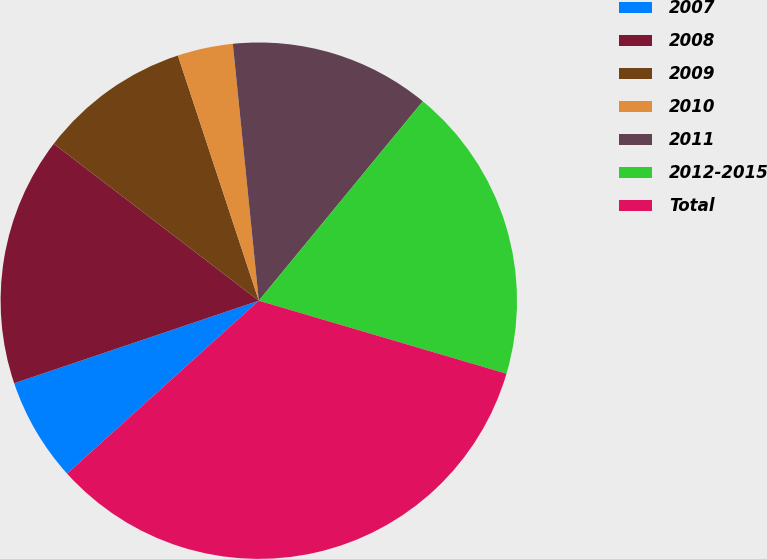<chart> <loc_0><loc_0><loc_500><loc_500><pie_chart><fcel>2007<fcel>2008<fcel>2009<fcel>2010<fcel>2011<fcel>2012-2015<fcel>Total<nl><fcel>6.5%<fcel>15.58%<fcel>9.53%<fcel>3.47%<fcel>12.56%<fcel>18.61%<fcel>33.76%<nl></chart> 